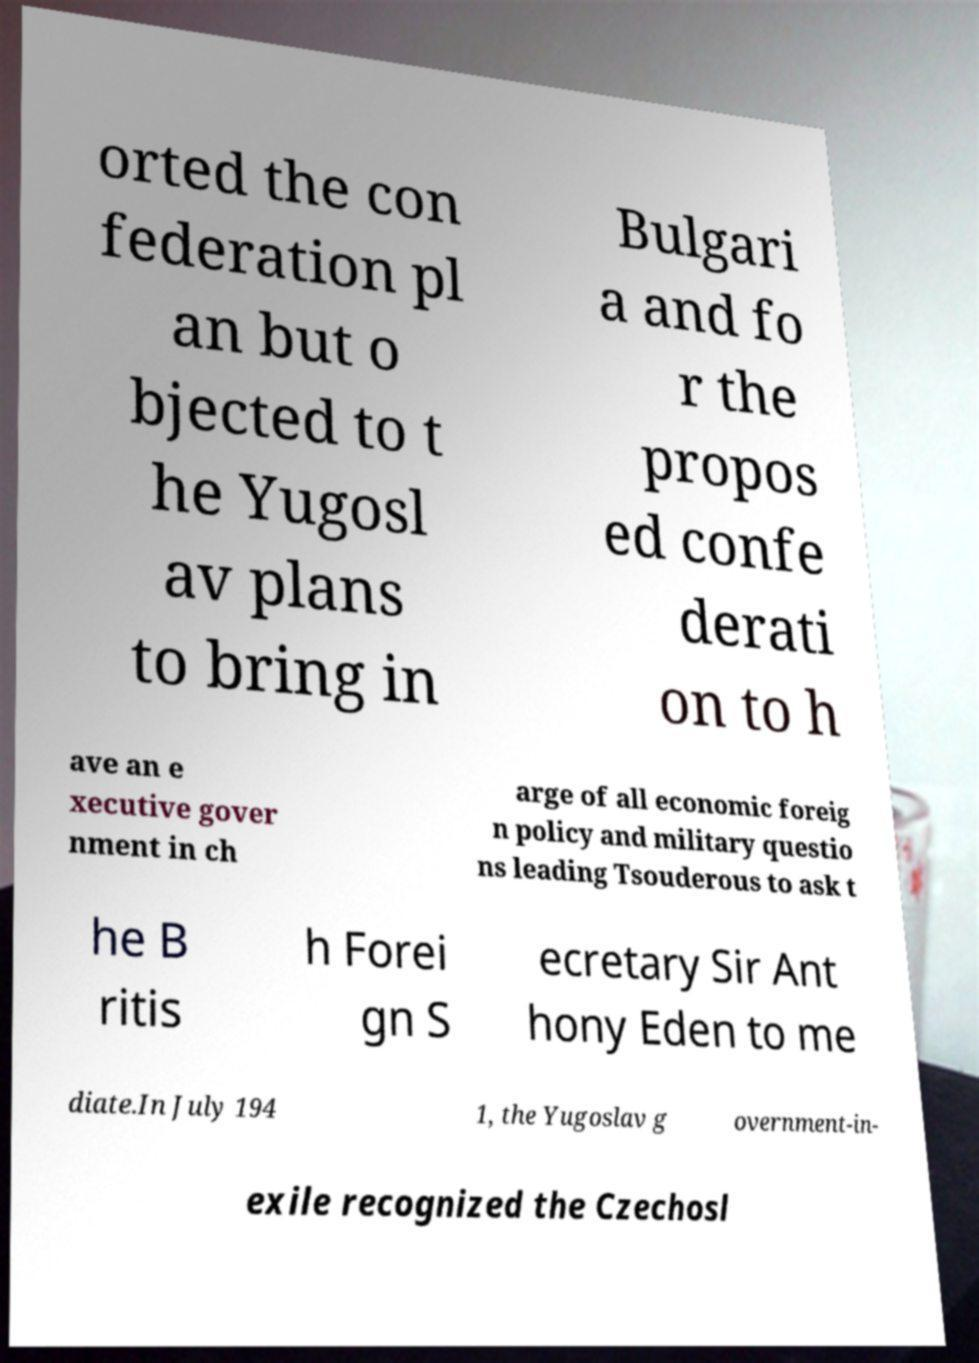Can you accurately transcribe the text from the provided image for me? orted the con federation pl an but o bjected to t he Yugosl av plans to bring in Bulgari a and fo r the propos ed confe derati on to h ave an e xecutive gover nment in ch arge of all economic foreig n policy and military questio ns leading Tsouderous to ask t he B ritis h Forei gn S ecretary Sir Ant hony Eden to me diate.In July 194 1, the Yugoslav g overnment-in- exile recognized the Czechosl 